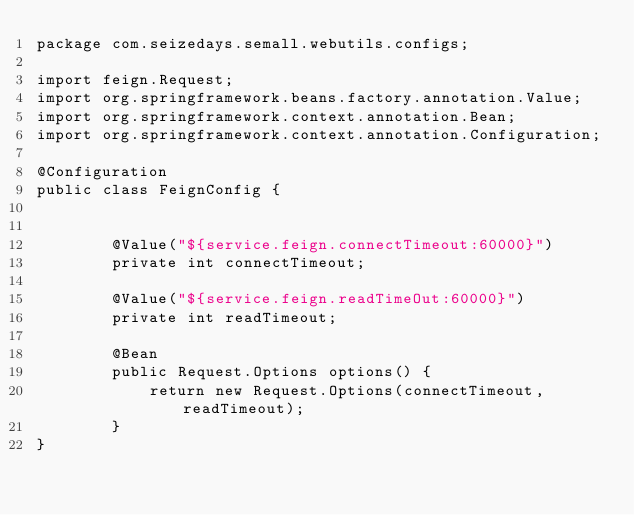<code> <loc_0><loc_0><loc_500><loc_500><_Java_>package com.seizedays.semall.webutils.configs;

import feign.Request;
import org.springframework.beans.factory.annotation.Value;
import org.springframework.context.annotation.Bean;
import org.springframework.context.annotation.Configuration;

@Configuration
public class FeignConfig {


        @Value("${service.feign.connectTimeout:60000}")
        private int connectTimeout;

        @Value("${service.feign.readTimeOut:60000}")
        private int readTimeout;

        @Bean
        public Request.Options options() {
            return new Request.Options(connectTimeout, readTimeout);
        }
}
</code> 